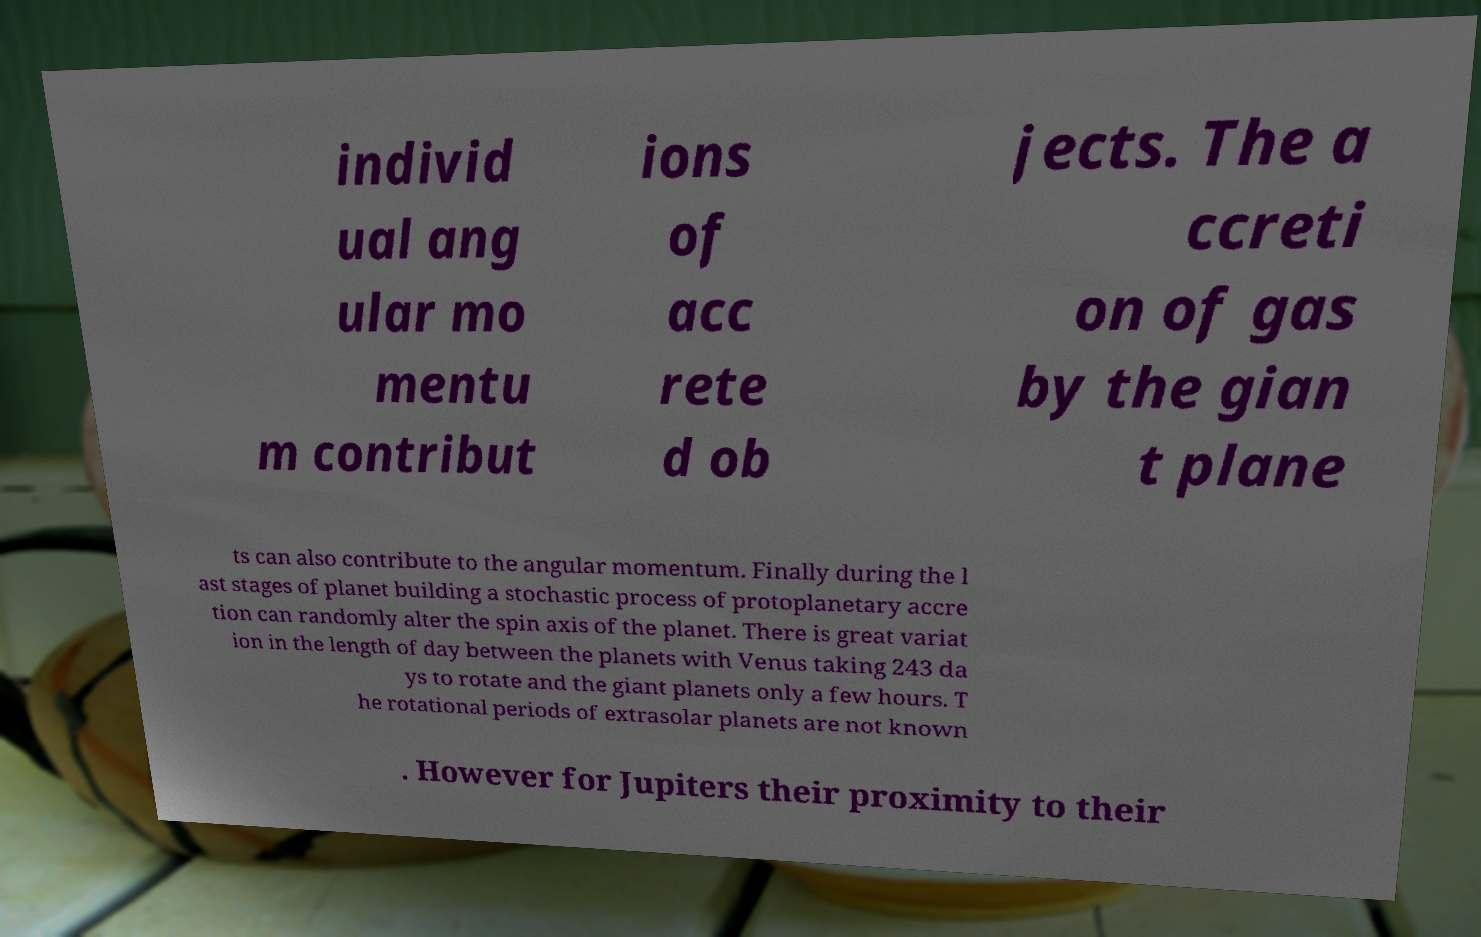Please read and relay the text visible in this image. What does it say? individ ual ang ular mo mentu m contribut ions of acc rete d ob jects. The a ccreti on of gas by the gian t plane ts can also contribute to the angular momentum. Finally during the l ast stages of planet building a stochastic process of protoplanetary accre tion can randomly alter the spin axis of the planet. There is great variat ion in the length of day between the planets with Venus taking 243 da ys to rotate and the giant planets only a few hours. T he rotational periods of extrasolar planets are not known . However for Jupiters their proximity to their 